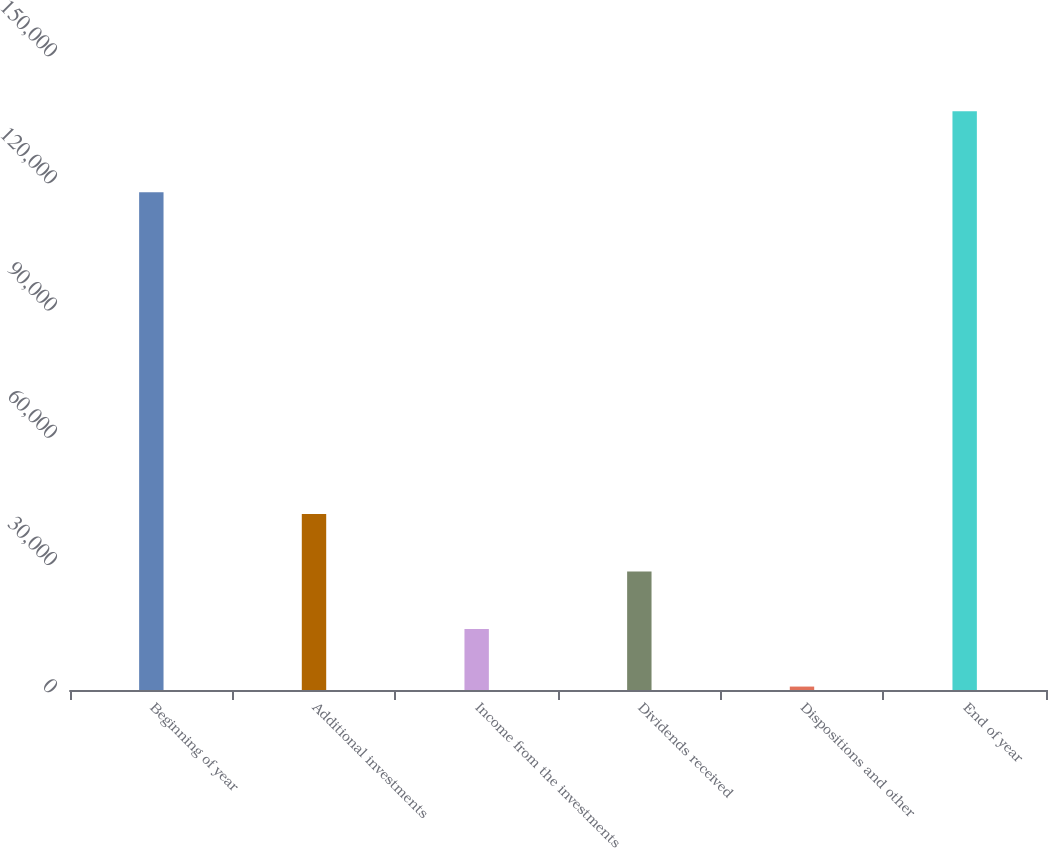Convert chart. <chart><loc_0><loc_0><loc_500><loc_500><bar_chart><fcel>Beginning of year<fcel>Additional investments<fcel>Income from the investments<fcel>Dividends received<fcel>Dispositions and other<fcel>End of year<nl><fcel>117378<fcel>41513.1<fcel>14377.7<fcel>27945.4<fcel>810<fcel>136487<nl></chart> 